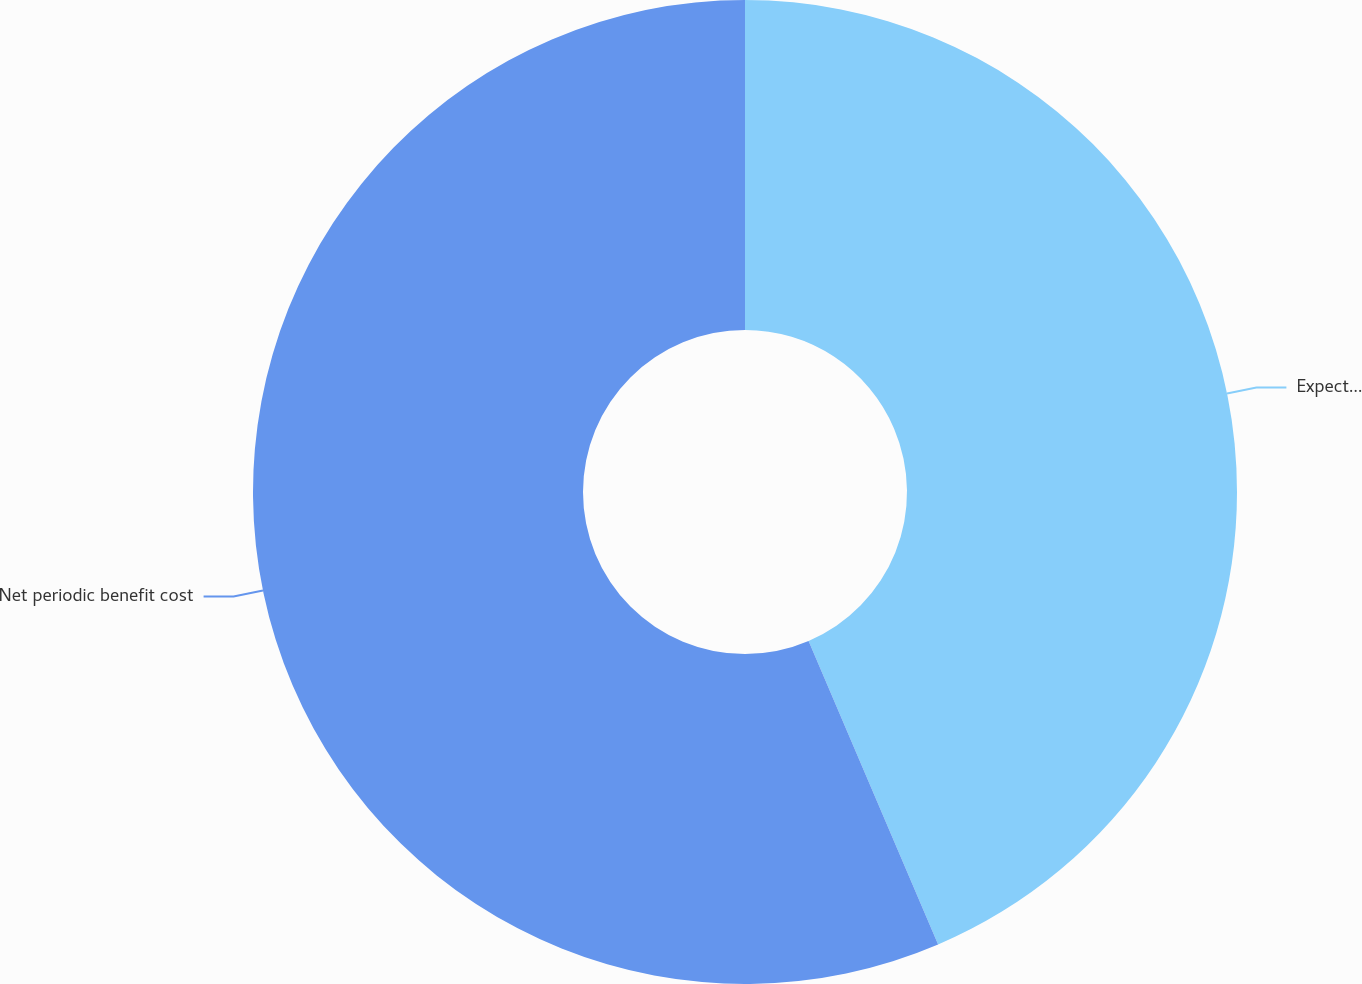Convert chart to OTSL. <chart><loc_0><loc_0><loc_500><loc_500><pie_chart><fcel>Expected return on plan assets<fcel>Net periodic benefit cost<nl><fcel>43.58%<fcel>56.42%<nl></chart> 